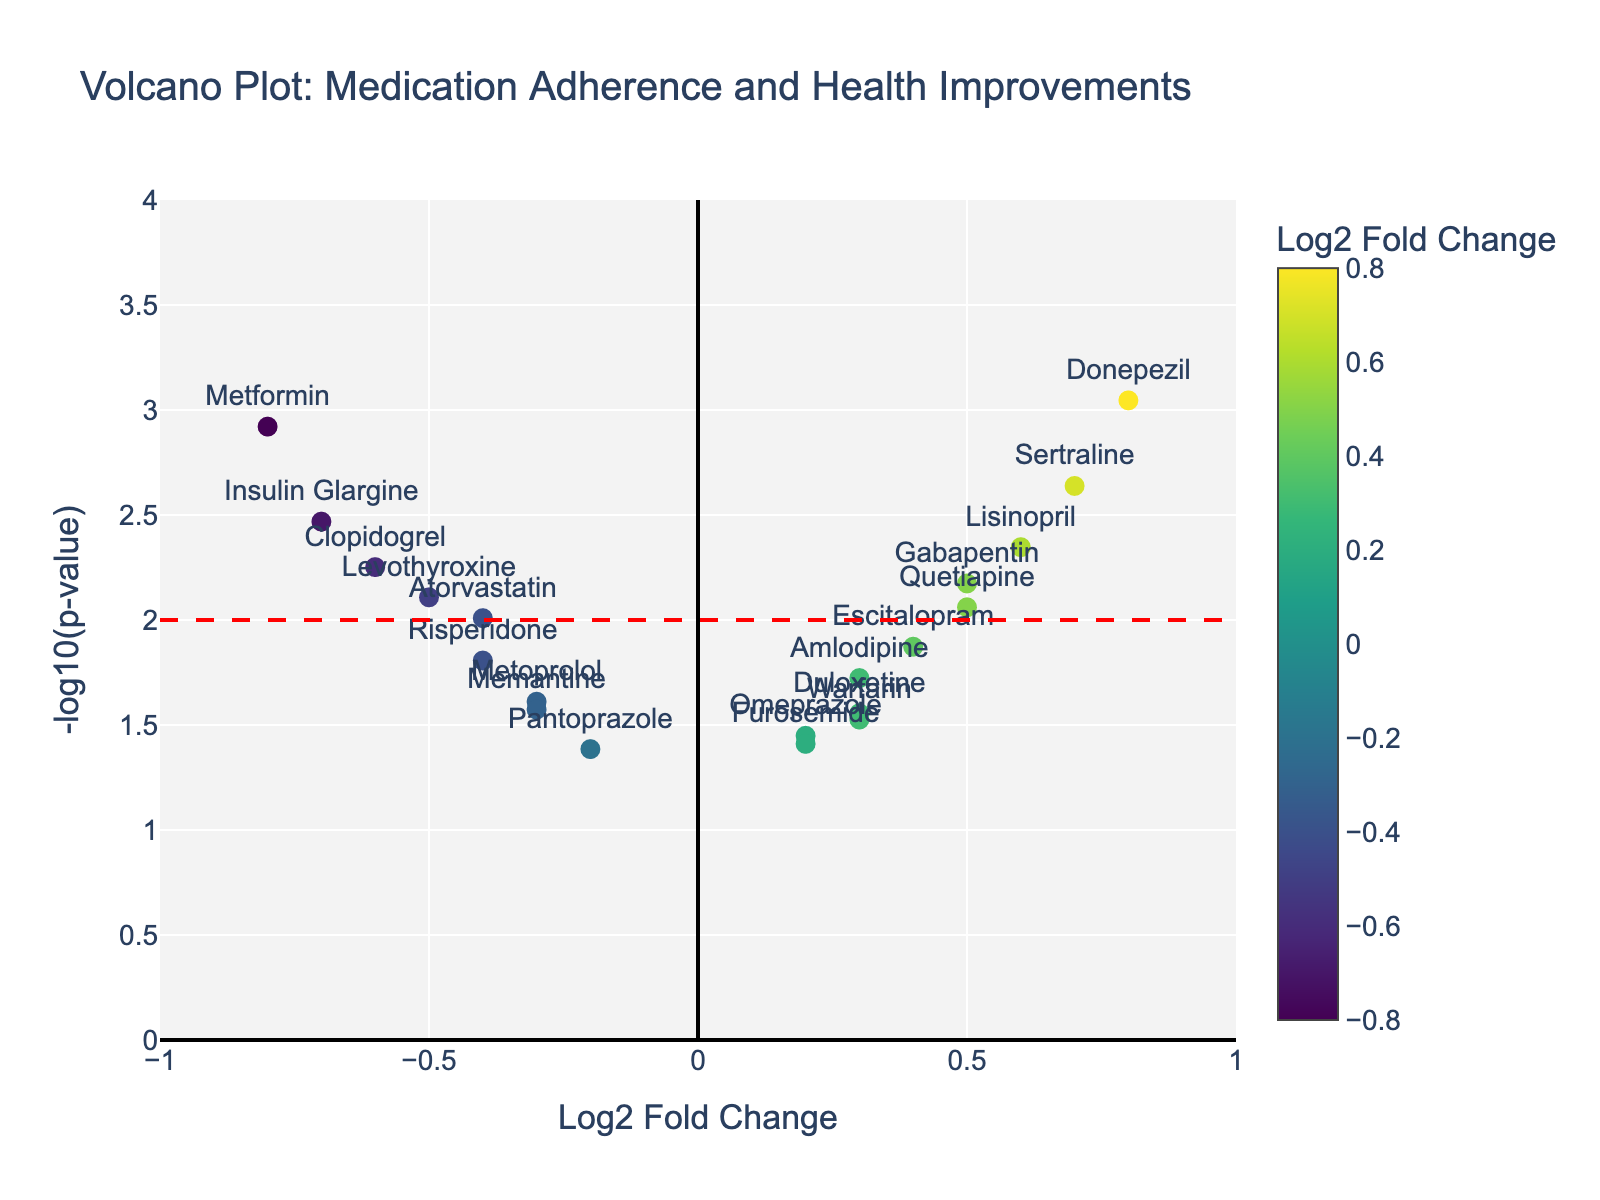What does the title of the plot represent? The title of the plot is "Volcano Plot: Medication Adherence and Health Improvements", which represents the relationship between medication adherence and health improvements in long-term care facilities using a volcano plot.
Answer: Volcano Plot: Medication Adherence and Health Improvements What does the x-axis on the plot represent? The x-axis represents the Log2 Fold Change of the medications, which shows the magnitude of change in health improvements associated with medication adherence.
Answer: Log2 Fold Change What does the y-axis on the plot represent? The y-axis represents the -log10(p-value) of the medications, which indicates the statistical significance of the changes. Higher values signify more significant results.
Answer: -log10(p-value) How many medications have a Log2 Fold Change greater than 0.5? To determine this, look at the data points to the right of 0.5 on the x-axis. These medications are Sertraline and Donepezil.
Answer: 2 Which medication has the highest -log10(p-value)? Identify the highest point on the y-axis. The highest -log10(p-value) corresponds to Donepezil.
Answer: Donepezil What range of Log2 Fold Change values is covered in the plot? The x-axis range for Log2 Fold Change in the plot spans from -1 to 1, as indicated by the axis limits.
Answer: -1 to 1 Which medications show a significant negative fold change? Medications with a significant fold change would have a -log10(p-value) above 2 and a Log2 Fold Change less than 0. These medications are Metformin, Clopidogrel, and Insulin Glargine.
Answer: Metformin, Clopidogrel, Insulin Glargine Compare Metformin and Donepezil: Which one has a more significant p-value and which one shows more change in health improvements? Donepezil has a higher -log10(p-value) (indicating a more significant p-value), and Donepezil also shows a more positive change in health improvements with a higher Log2 Fold Change value than Metformin.
Answer: Donepezil, Donepezil What is the significance threshold used in the plot, and how can you tell? The significance threshold is marked by the horizontal red dashed line on the plot, set at -log10(p-value) = 2, translating to a p-value of 0.01.
Answer: -log10(p-value) = 2 Find a medication with approximately neutral Log2 Fold Change but still significant p-value. Look for a data point around 0 on the x-axis but above the significance line on the y-axis. Escitalopram has a Log2 Fold Change close to 0 and a significant p-value.
Answer: Escitalopram 